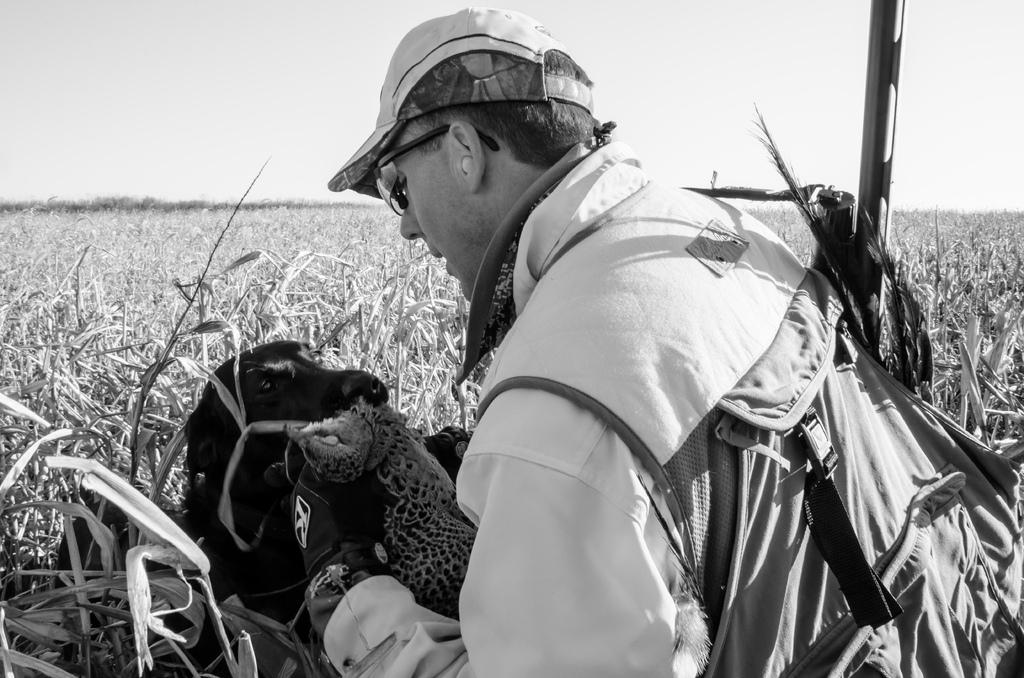What is the main subject of the image? The main subject of the image is a man. What is the man wearing on his head? The man is wearing a cap. What is the man wearing to protect his eyes? The man is wearing goggles. What is the man wearing on his hands? The man is wearing gloves. What can be seen in front of the man? There is a dog and some objects in front of the man. What can be seen in the background of the image? There are plants and the sky visible in the background of the image. How much money is the man holding in the image? There is no indication of money in the image; the man is wearing gloves and is not holding any visible objects that could be interpreted as money. 